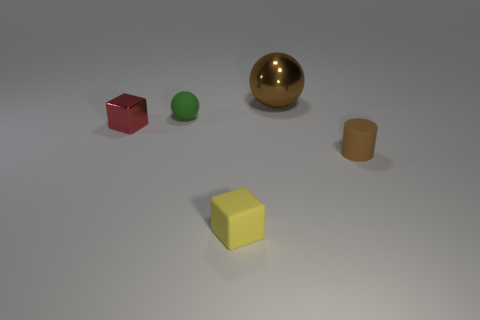There is a small rubber thing that is on the right side of the large brown sphere; does it have the same color as the small block to the left of the yellow matte block?
Offer a terse response. No. Are there fewer tiny red metallic things than balls?
Your answer should be compact. Yes. There is a brown object that is behind the small matte thing that is behind the tiny cylinder; what shape is it?
Make the answer very short. Sphere. Are there any other things that have the same size as the green ball?
Your response must be concise. Yes. The object in front of the tiny thing that is to the right of the brown object behind the small red metallic block is what shape?
Keep it short and to the point. Cube. How many things are metal things in front of the big brown object or small rubber objects on the right side of the green ball?
Ensure brevity in your answer.  3. There is a metal ball; is it the same size as the rubber object that is behind the brown matte cylinder?
Your answer should be compact. No. Is the thing on the right side of the large brown object made of the same material as the tiny cube that is to the left of the small yellow block?
Your answer should be compact. No. Is the number of brown spheres to the left of the large metallic sphere the same as the number of red blocks that are in front of the small red shiny cube?
Provide a short and direct response. Yes. How many small rubber things have the same color as the big shiny ball?
Provide a short and direct response. 1. 